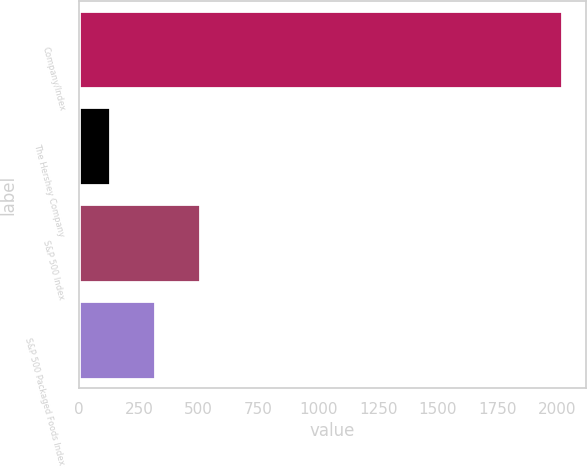Convert chart to OTSL. <chart><loc_0><loc_0><loc_500><loc_500><bar_chart><fcel>Company/Index<fcel>The Hershey Company<fcel>S&P 500 Index<fcel>S&P 500 Packaged Foods Index<nl><fcel>2017<fcel>128<fcel>505.8<fcel>316.9<nl></chart> 